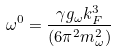Convert formula to latex. <formula><loc_0><loc_0><loc_500><loc_500>\omega ^ { 0 } = \frac { \gamma g _ { \omega } k _ { F } ^ { 3 } } { ( 6 \pi ^ { 2 } m _ { \omega } ^ { 2 } ) }</formula> 